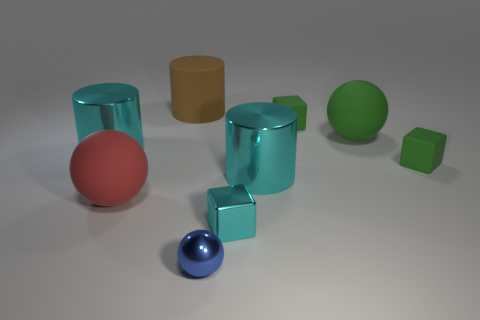How many big yellow spheres are there?
Provide a succinct answer. 0. Does the large brown matte thing have the same shape as the big cyan thing to the right of the red ball?
Give a very brief answer. Yes. How big is the red thing that is to the left of the large green ball?
Provide a succinct answer. Large. What material is the tiny blue thing?
Provide a succinct answer. Metal. There is a large cyan metal thing that is to the right of the tiny cyan cube; does it have the same shape as the brown rubber thing?
Give a very brief answer. Yes. Is there a cyan cylinder that has the same size as the red sphere?
Your response must be concise. Yes. Is there a brown cylinder that is behind the big cyan object right of the large cyan metal thing that is on the left side of the large brown cylinder?
Give a very brief answer. Yes. There is a small metal block; is it the same color as the big metallic object right of the metal block?
Your answer should be compact. Yes. What is the material of the small green thing that is behind the cube to the right of the large ball that is behind the large red thing?
Offer a very short reply. Rubber. The object that is on the left side of the large red object has what shape?
Provide a succinct answer. Cylinder. 